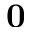Convert formula to latex. <formula><loc_0><loc_0><loc_500><loc_500>0</formula> 